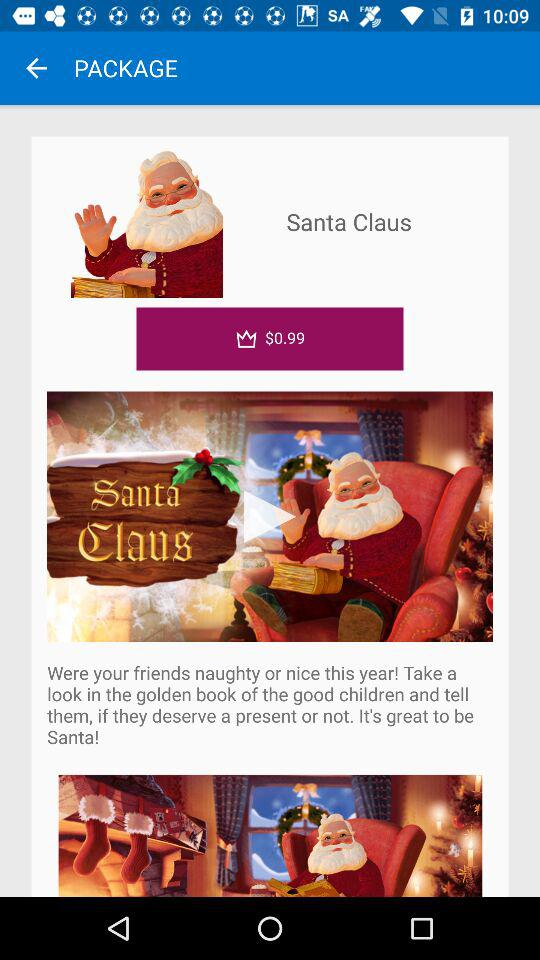What is the name of the book? The name of the book is "Santa Claus". 